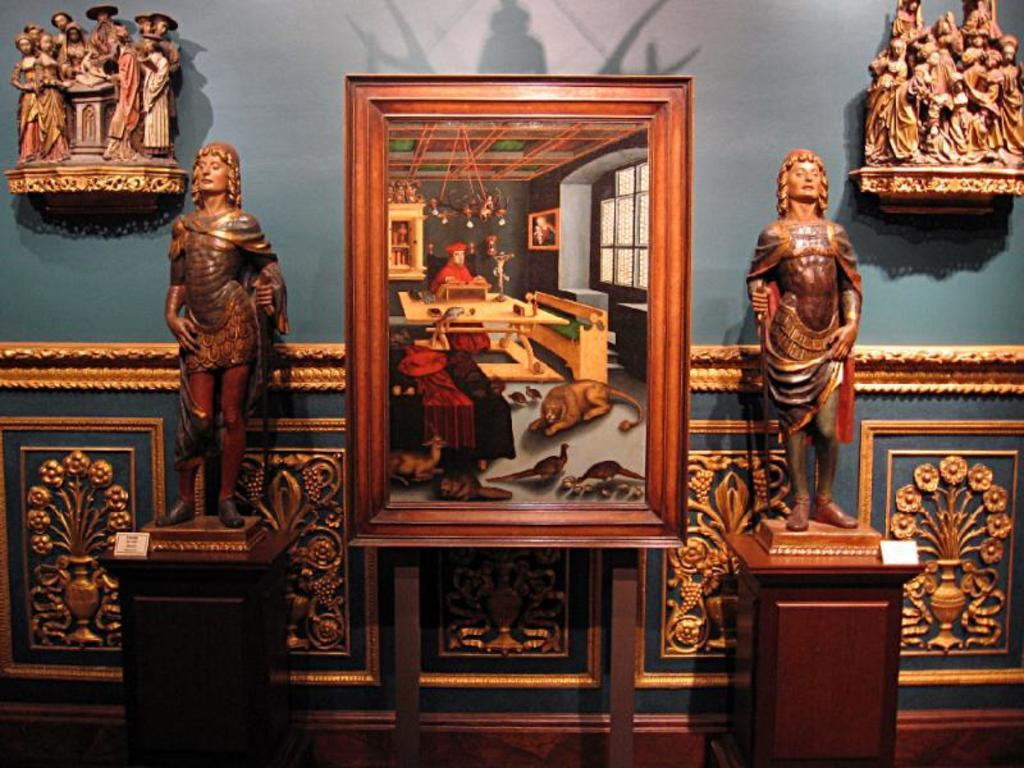What type of objects can be seen in the image? There are statues in the image. Is there any other object related to the statues? Yes, there is a frame in the image. What can be seen on the wall in the background of the image? There are sculptures on the wall in the background of the image. How many roses are on the legs of the statues in the image? There are no roses or legs mentioned in the image; it only features statues, a frame, and sculptures on the wall. 